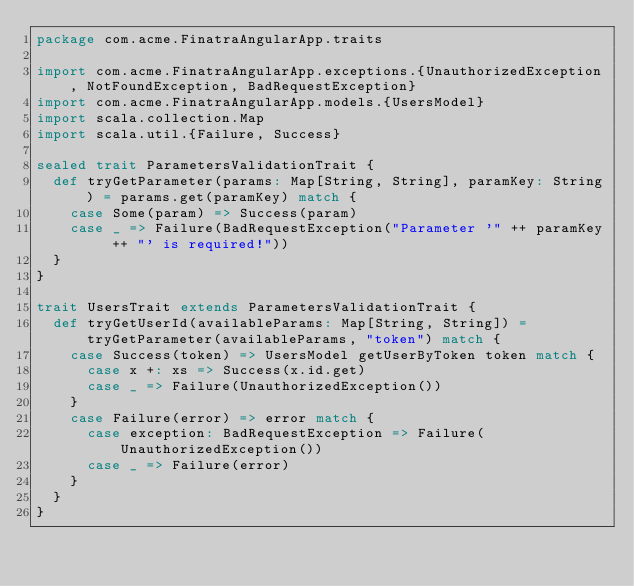Convert code to text. <code><loc_0><loc_0><loc_500><loc_500><_Scala_>package com.acme.FinatraAngularApp.traits

import com.acme.FinatraAngularApp.exceptions.{UnauthorizedException, NotFoundException, BadRequestException}
import com.acme.FinatraAngularApp.models.{UsersModel}
import scala.collection.Map
import scala.util.{Failure, Success}

sealed trait ParametersValidationTrait {
  def tryGetParameter(params: Map[String, String], paramKey: String) = params.get(paramKey) match {
    case Some(param) => Success(param)
    case _ => Failure(BadRequestException("Parameter '" ++ paramKey ++ "' is required!"))
  }
}

trait UsersTrait extends ParametersValidationTrait {
  def tryGetUserId(availableParams: Map[String, String]) = tryGetParameter(availableParams, "token") match {
    case Success(token) => UsersModel getUserByToken token match {
      case x +: xs => Success(x.id.get)
      case _ => Failure(UnauthorizedException())
    }
    case Failure(error) => error match {
      case exception: BadRequestException => Failure(UnauthorizedException())
      case _ => Failure(error)
    }
  }
}</code> 